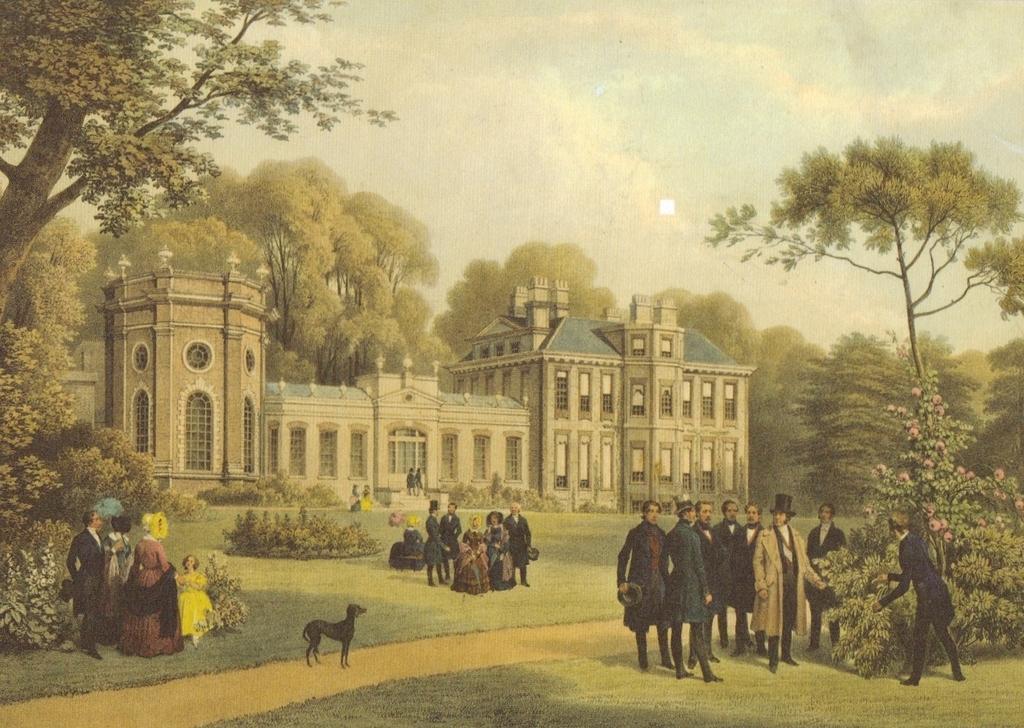Describe this image in one or two sentences. It's a picture and on the right side few men are standing, on the left side there is a dog and there are trees. This is a building in the middle of an image. At the top it's a cloudy sky. 